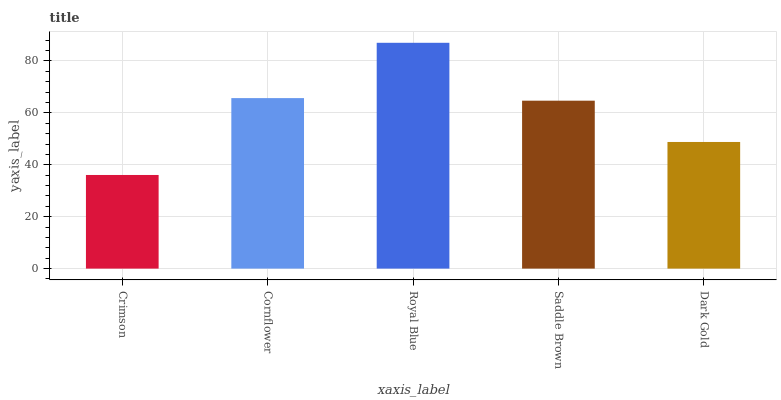Is Crimson the minimum?
Answer yes or no. Yes. Is Royal Blue the maximum?
Answer yes or no. Yes. Is Cornflower the minimum?
Answer yes or no. No. Is Cornflower the maximum?
Answer yes or no. No. Is Cornflower greater than Crimson?
Answer yes or no. Yes. Is Crimson less than Cornflower?
Answer yes or no. Yes. Is Crimson greater than Cornflower?
Answer yes or no. No. Is Cornflower less than Crimson?
Answer yes or no. No. Is Saddle Brown the high median?
Answer yes or no. Yes. Is Saddle Brown the low median?
Answer yes or no. Yes. Is Dark Gold the high median?
Answer yes or no. No. Is Royal Blue the low median?
Answer yes or no. No. 